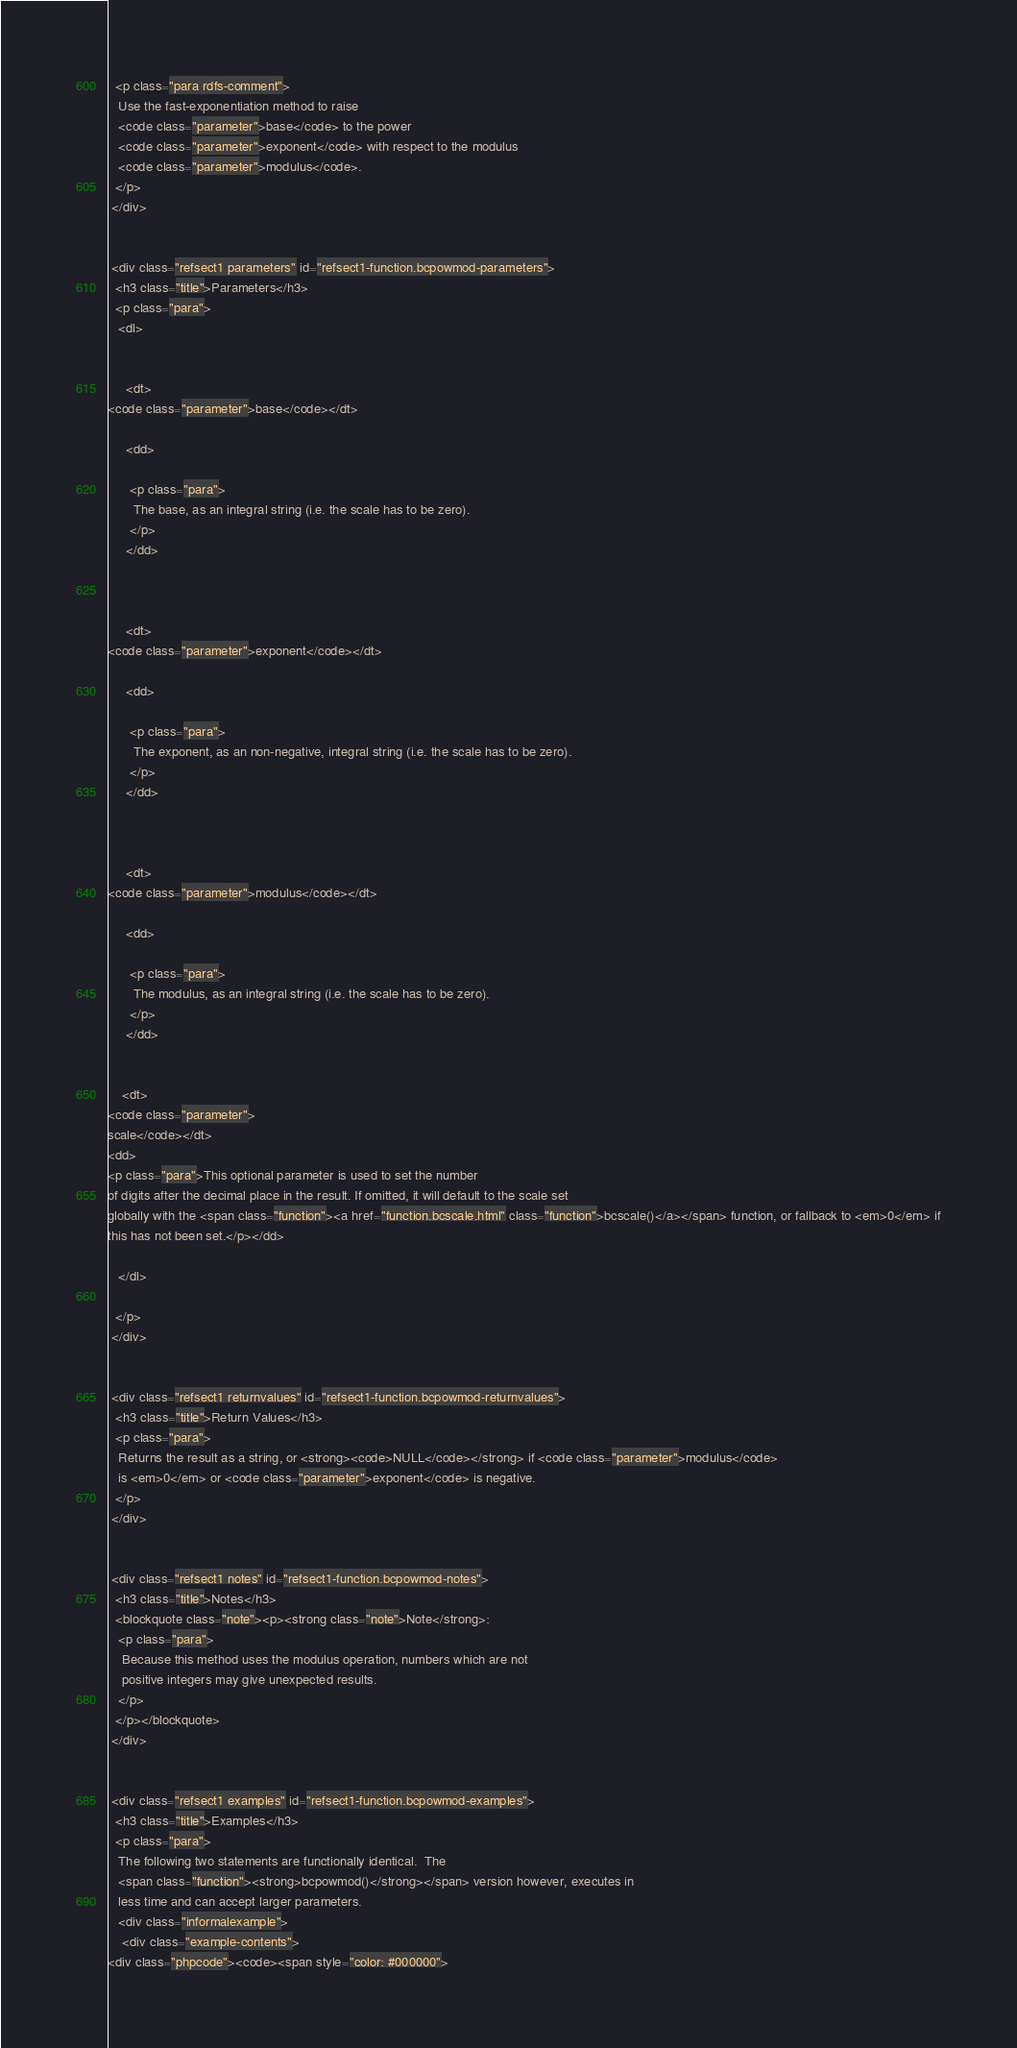Convert code to text. <code><loc_0><loc_0><loc_500><loc_500><_HTML_>  <p class="para rdfs-comment">
   Use the fast-exponentiation method to raise 
   <code class="parameter">base</code> to the power
   <code class="parameter">exponent</code> with respect to the modulus
   <code class="parameter">modulus</code>.
  </p>
 </div>


 <div class="refsect1 parameters" id="refsect1-function.bcpowmod-parameters">
  <h3 class="title">Parameters</h3>
  <p class="para">
   <dl>

    
     <dt>
<code class="parameter">base</code></dt>

     <dd>

      <p class="para">
       The base, as an integral string (i.e. the scale has to be zero).
      </p>
     </dd>

    
    
     <dt>
<code class="parameter">exponent</code></dt>

     <dd>

      <p class="para">
       The exponent, as an non-negative, integral string (i.e. the scale has to be zero).
      </p>
     </dd>

    
    
     <dt>
<code class="parameter">modulus</code></dt>

     <dd>

      <p class="para">
       The modulus, as an integral string (i.e. the scale has to be zero).
      </p>
     </dd>

    
    <dt>
<code class="parameter">
scale</code></dt>
<dd>
<p class="para">This optional parameter is used to set the number
of digits after the decimal place in the result. If omitted, it will default to the scale set
globally with the <span class="function"><a href="function.bcscale.html" class="function">bcscale()</a></span> function, or fallback to <em>0</em> if
this has not been set.</p></dd>

   </dl>

  </p>
 </div>


 <div class="refsect1 returnvalues" id="refsect1-function.bcpowmod-returnvalues">
  <h3 class="title">Return Values</h3>
  <p class="para">
   Returns the result as a string, or <strong><code>NULL</code></strong> if <code class="parameter">modulus</code>
   is <em>0</em> or <code class="parameter">exponent</code> is negative.
  </p>
 </div>

 
 <div class="refsect1 notes" id="refsect1-function.bcpowmod-notes">
  <h3 class="title">Notes</h3>
  <blockquote class="note"><p><strong class="note">Note</strong>: 
   <p class="para">
    Because this method uses the modulus operation, numbers which are not
    positive integers may give unexpected results.
   </p>
  </p></blockquote>
 </div>

 
 <div class="refsect1 examples" id="refsect1-function.bcpowmod-examples">
  <h3 class="title">Examples</h3>
  <p class="para">
   The following two statements are functionally identical.  The
   <span class="function"><strong>bcpowmod()</strong></span> version however, executes in
   less time and can accept larger parameters.
   <div class="informalexample">
    <div class="example-contents">
<div class="phpcode"><code><span style="color: #000000"></code> 